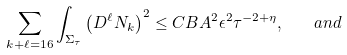<formula> <loc_0><loc_0><loc_500><loc_500>\sum _ { k + \ell = 1 6 } \int _ { \Sigma _ { \tau } } \left ( D ^ { \ell } N _ { k } \right ) ^ { 2 } \leq C B A ^ { 2 } \epsilon ^ { 2 } \tau ^ { - 2 + \eta } , \quad a n d</formula> 